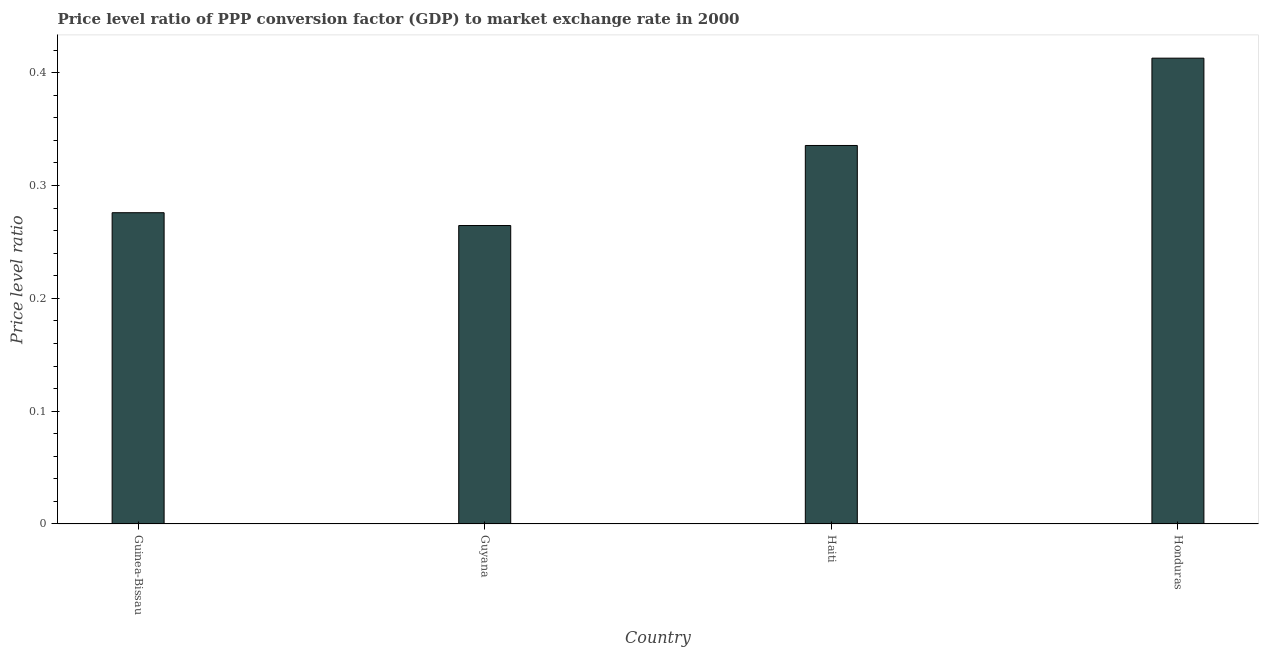Does the graph contain any zero values?
Give a very brief answer. No. What is the title of the graph?
Make the answer very short. Price level ratio of PPP conversion factor (GDP) to market exchange rate in 2000. What is the label or title of the Y-axis?
Offer a terse response. Price level ratio. What is the price level ratio in Guyana?
Your answer should be compact. 0.26. Across all countries, what is the maximum price level ratio?
Your answer should be very brief. 0.41. Across all countries, what is the minimum price level ratio?
Offer a terse response. 0.26. In which country was the price level ratio maximum?
Your answer should be compact. Honduras. In which country was the price level ratio minimum?
Make the answer very short. Guyana. What is the sum of the price level ratio?
Keep it short and to the point. 1.29. What is the difference between the price level ratio in Guinea-Bissau and Guyana?
Keep it short and to the point. 0.01. What is the average price level ratio per country?
Your answer should be compact. 0.32. What is the median price level ratio?
Ensure brevity in your answer.  0.31. In how many countries, is the price level ratio greater than 0.22 ?
Offer a terse response. 4. What is the ratio of the price level ratio in Guyana to that in Haiti?
Offer a terse response. 0.79. Is the price level ratio in Guinea-Bissau less than that in Guyana?
Offer a terse response. No. What is the difference between the highest and the second highest price level ratio?
Keep it short and to the point. 0.08. Is the sum of the price level ratio in Guinea-Bissau and Honduras greater than the maximum price level ratio across all countries?
Your answer should be very brief. Yes. What is the difference between the highest and the lowest price level ratio?
Your answer should be very brief. 0.15. How many countries are there in the graph?
Your answer should be very brief. 4. What is the difference between two consecutive major ticks on the Y-axis?
Keep it short and to the point. 0.1. What is the Price level ratio in Guinea-Bissau?
Offer a terse response. 0.28. What is the Price level ratio of Guyana?
Keep it short and to the point. 0.26. What is the Price level ratio of Haiti?
Your response must be concise. 0.34. What is the Price level ratio of Honduras?
Make the answer very short. 0.41. What is the difference between the Price level ratio in Guinea-Bissau and Guyana?
Offer a terse response. 0.01. What is the difference between the Price level ratio in Guinea-Bissau and Haiti?
Provide a short and direct response. -0.06. What is the difference between the Price level ratio in Guinea-Bissau and Honduras?
Your response must be concise. -0.14. What is the difference between the Price level ratio in Guyana and Haiti?
Offer a terse response. -0.07. What is the difference between the Price level ratio in Guyana and Honduras?
Provide a short and direct response. -0.15. What is the difference between the Price level ratio in Haiti and Honduras?
Make the answer very short. -0.08. What is the ratio of the Price level ratio in Guinea-Bissau to that in Guyana?
Offer a terse response. 1.04. What is the ratio of the Price level ratio in Guinea-Bissau to that in Haiti?
Provide a short and direct response. 0.82. What is the ratio of the Price level ratio in Guinea-Bissau to that in Honduras?
Your answer should be compact. 0.67. What is the ratio of the Price level ratio in Guyana to that in Haiti?
Offer a terse response. 0.79. What is the ratio of the Price level ratio in Guyana to that in Honduras?
Make the answer very short. 0.64. What is the ratio of the Price level ratio in Haiti to that in Honduras?
Your answer should be compact. 0.81. 